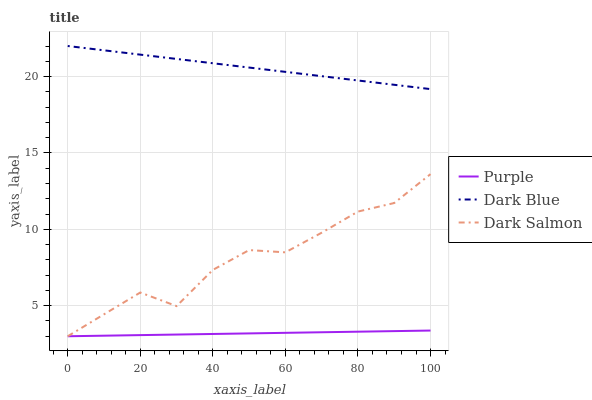Does Dark Salmon have the minimum area under the curve?
Answer yes or no. No. Does Dark Salmon have the maximum area under the curve?
Answer yes or no. No. Is Dark Blue the smoothest?
Answer yes or no. No. Is Dark Blue the roughest?
Answer yes or no. No. Does Dark Blue have the lowest value?
Answer yes or no. No. Does Dark Salmon have the highest value?
Answer yes or no. No. Is Dark Salmon less than Dark Blue?
Answer yes or no. Yes. Is Dark Blue greater than Purple?
Answer yes or no. Yes. Does Dark Salmon intersect Dark Blue?
Answer yes or no. No. 